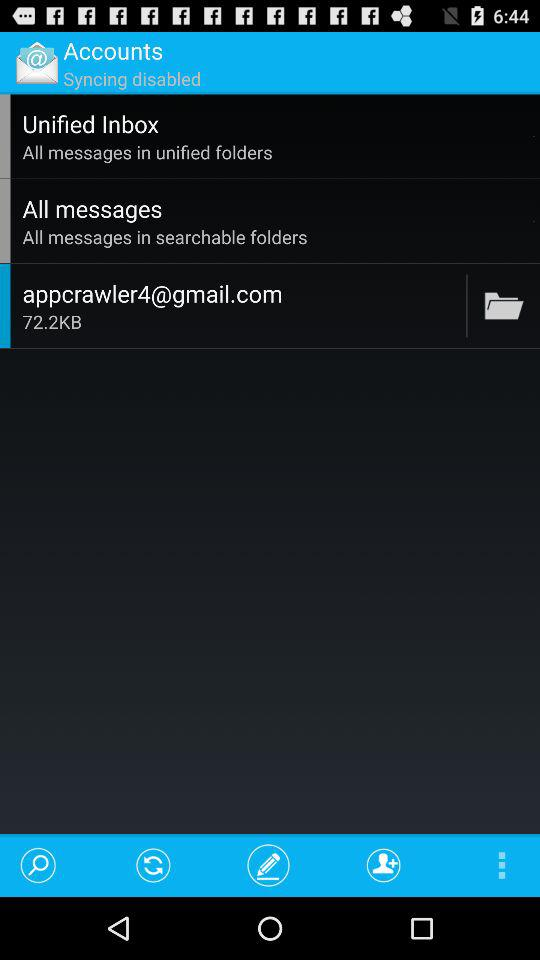What is the size? The size is 72.2KB. 